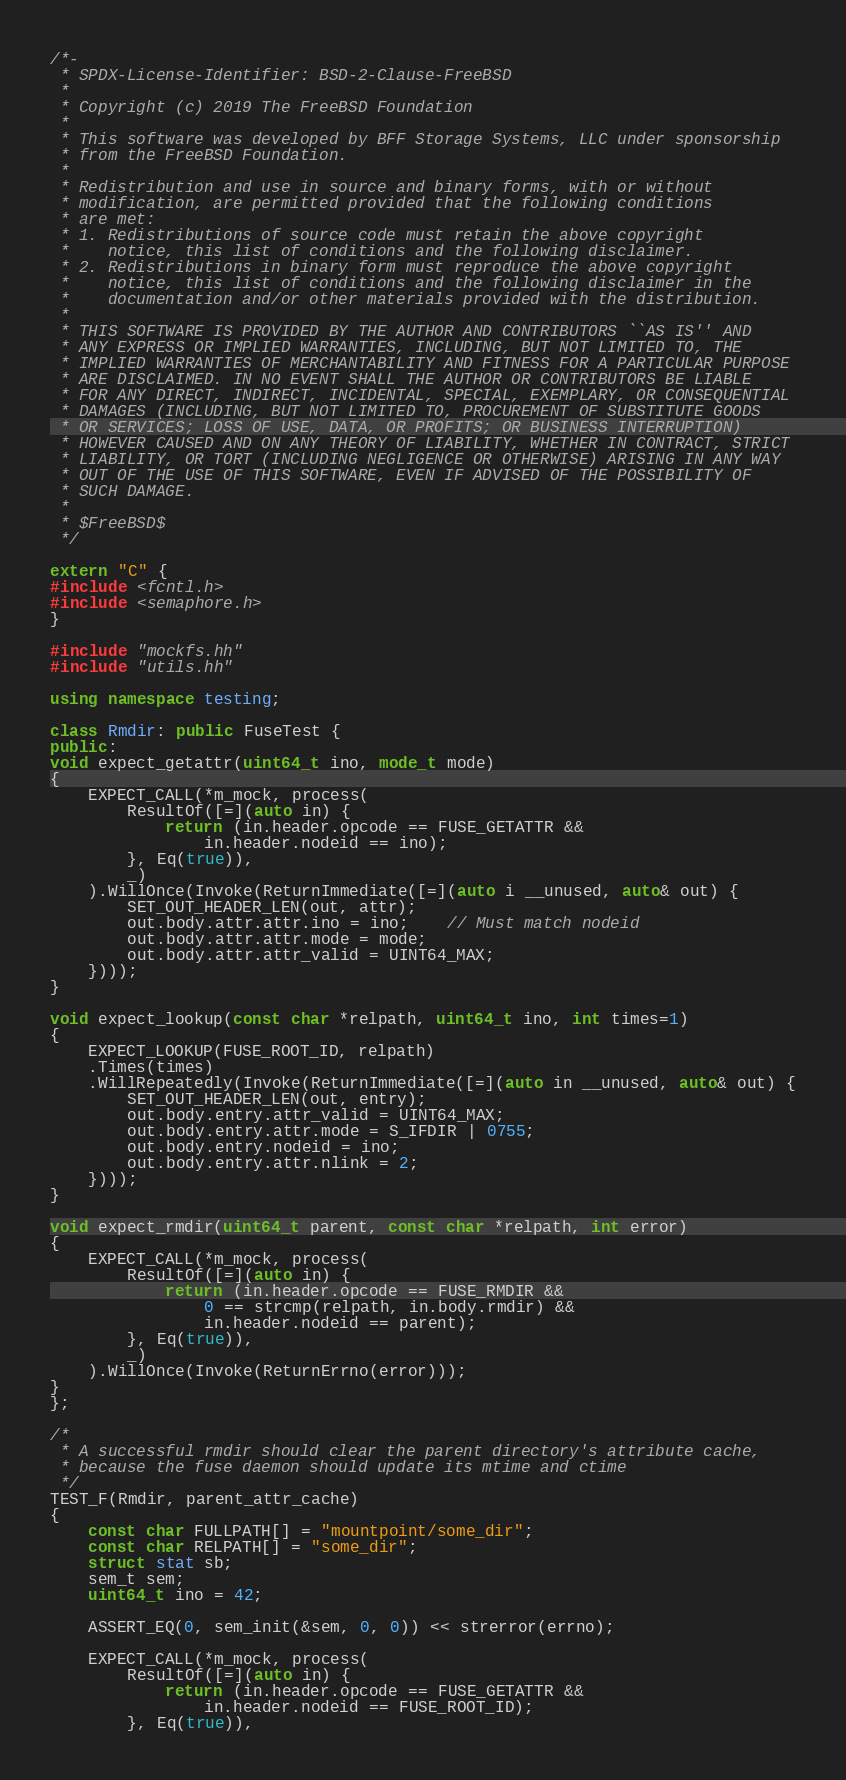<code> <loc_0><loc_0><loc_500><loc_500><_C++_>/*-
 * SPDX-License-Identifier: BSD-2-Clause-FreeBSD
 *
 * Copyright (c) 2019 The FreeBSD Foundation
 *
 * This software was developed by BFF Storage Systems, LLC under sponsorship
 * from the FreeBSD Foundation.
 *
 * Redistribution and use in source and binary forms, with or without
 * modification, are permitted provided that the following conditions
 * are met:
 * 1. Redistributions of source code must retain the above copyright
 *    notice, this list of conditions and the following disclaimer.
 * 2. Redistributions in binary form must reproduce the above copyright
 *    notice, this list of conditions and the following disclaimer in the
 *    documentation and/or other materials provided with the distribution.
 *
 * THIS SOFTWARE IS PROVIDED BY THE AUTHOR AND CONTRIBUTORS ``AS IS'' AND
 * ANY EXPRESS OR IMPLIED WARRANTIES, INCLUDING, BUT NOT LIMITED TO, THE
 * IMPLIED WARRANTIES OF MERCHANTABILITY AND FITNESS FOR A PARTICULAR PURPOSE
 * ARE DISCLAIMED. IN NO EVENT SHALL THE AUTHOR OR CONTRIBUTORS BE LIABLE
 * FOR ANY DIRECT, INDIRECT, INCIDENTAL, SPECIAL, EXEMPLARY, OR CONSEQUENTIAL
 * DAMAGES (INCLUDING, BUT NOT LIMITED TO, PROCUREMENT OF SUBSTITUTE GOODS
 * OR SERVICES; LOSS OF USE, DATA, OR PROFITS; OR BUSINESS INTERRUPTION)
 * HOWEVER CAUSED AND ON ANY THEORY OF LIABILITY, WHETHER IN CONTRACT, STRICT
 * LIABILITY, OR TORT (INCLUDING NEGLIGENCE OR OTHERWISE) ARISING IN ANY WAY
 * OUT OF THE USE OF THIS SOFTWARE, EVEN IF ADVISED OF THE POSSIBILITY OF
 * SUCH DAMAGE.
 *
 * $FreeBSD$
 */

extern "C" {
#include <fcntl.h>
#include <semaphore.h>
}

#include "mockfs.hh"
#include "utils.hh"

using namespace testing;

class Rmdir: public FuseTest {
public:
void expect_getattr(uint64_t ino, mode_t mode)
{
	EXPECT_CALL(*m_mock, process(
		ResultOf([=](auto in) {
			return (in.header.opcode == FUSE_GETATTR &&
				in.header.nodeid == ino);
		}, Eq(true)),
		_)
	).WillOnce(Invoke(ReturnImmediate([=](auto i __unused, auto& out) {
		SET_OUT_HEADER_LEN(out, attr);
		out.body.attr.attr.ino = ino;	// Must match nodeid
		out.body.attr.attr.mode = mode;
		out.body.attr.attr_valid = UINT64_MAX;
	})));
}

void expect_lookup(const char *relpath, uint64_t ino, int times=1)
{
	EXPECT_LOOKUP(FUSE_ROOT_ID, relpath)
	.Times(times)
	.WillRepeatedly(Invoke(ReturnImmediate([=](auto in __unused, auto& out) {
		SET_OUT_HEADER_LEN(out, entry);
		out.body.entry.attr_valid = UINT64_MAX;
		out.body.entry.attr.mode = S_IFDIR | 0755;
		out.body.entry.nodeid = ino;
		out.body.entry.attr.nlink = 2;
	})));
}

void expect_rmdir(uint64_t parent, const char *relpath, int error)
{
	EXPECT_CALL(*m_mock, process(
		ResultOf([=](auto in) {
			return (in.header.opcode == FUSE_RMDIR &&
				0 == strcmp(relpath, in.body.rmdir) &&
				in.header.nodeid == parent);
		}, Eq(true)),
		_)
	).WillOnce(Invoke(ReturnErrno(error)));
}
};

/*
 * A successful rmdir should clear the parent directory's attribute cache,
 * because the fuse daemon should update its mtime and ctime
 */
TEST_F(Rmdir, parent_attr_cache)
{
	const char FULLPATH[] = "mountpoint/some_dir";
	const char RELPATH[] = "some_dir";
	struct stat sb;
	sem_t sem;
	uint64_t ino = 42;

	ASSERT_EQ(0, sem_init(&sem, 0, 0)) << strerror(errno);

	EXPECT_CALL(*m_mock, process(
		ResultOf([=](auto in) {
			return (in.header.opcode == FUSE_GETATTR &&
				in.header.nodeid == FUSE_ROOT_ID);
		}, Eq(true)),</code> 